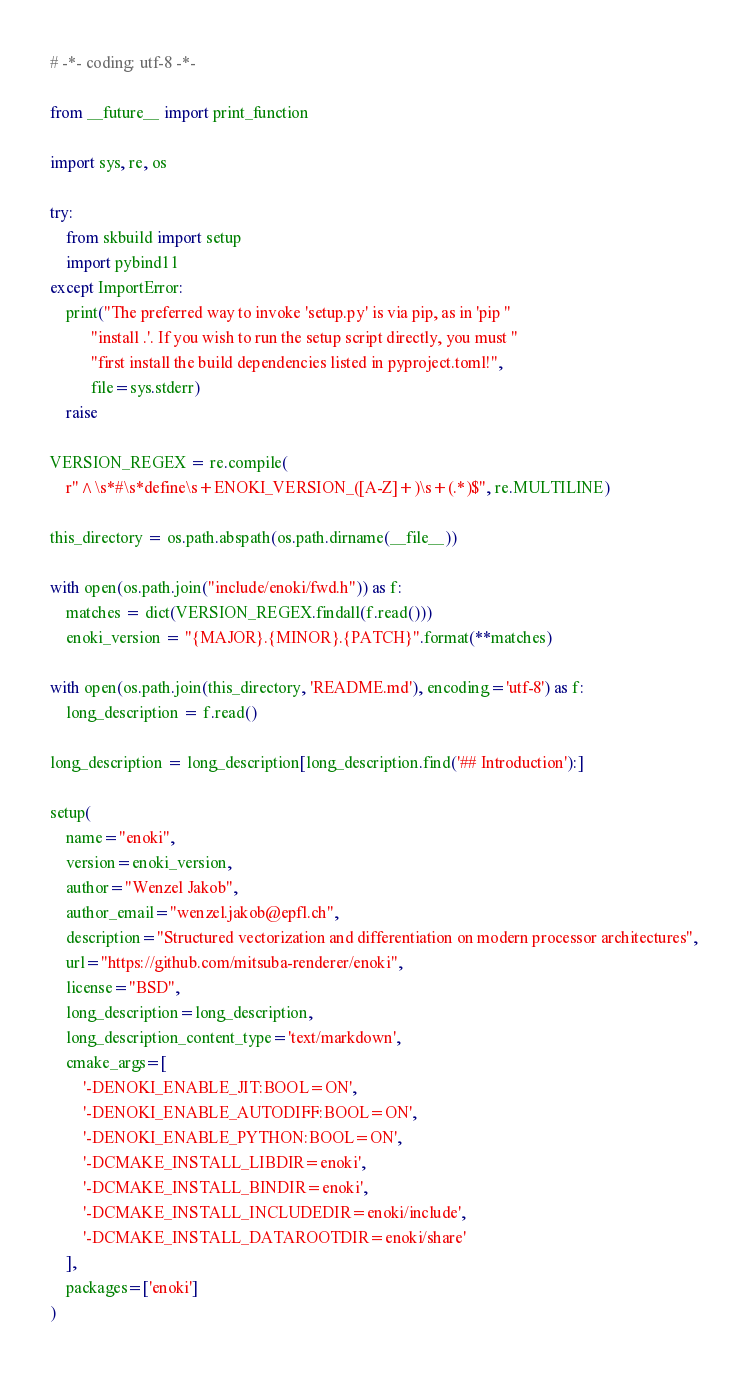<code> <loc_0><loc_0><loc_500><loc_500><_Python_># -*- coding: utf-8 -*-

from __future__ import print_function

import sys, re, os

try:
    from skbuild import setup
    import pybind11
except ImportError:
    print("The preferred way to invoke 'setup.py' is via pip, as in 'pip "
          "install .'. If you wish to run the setup script directly, you must "
          "first install the build dependencies listed in pyproject.toml!",
          file=sys.stderr)
    raise

VERSION_REGEX = re.compile(
    r"^\s*#\s*define\s+ENOKI_VERSION_([A-Z]+)\s+(.*)$", re.MULTILINE)

this_directory = os.path.abspath(os.path.dirname(__file__))

with open(os.path.join("include/enoki/fwd.h")) as f:
    matches = dict(VERSION_REGEX.findall(f.read()))
    enoki_version = "{MAJOR}.{MINOR}.{PATCH}".format(**matches)

with open(os.path.join(this_directory, 'README.md'), encoding='utf-8') as f:
    long_description = f.read()

long_description = long_description[long_description.find('## Introduction'):]

setup(
    name="enoki",
    version=enoki_version,
    author="Wenzel Jakob",
    author_email="wenzel.jakob@epfl.ch",
    description="Structured vectorization and differentiation on modern processor architectures",
    url="https://github.com/mitsuba-renderer/enoki",
    license="BSD",
    long_description=long_description,
    long_description_content_type='text/markdown',
    cmake_args=[
        '-DENOKI_ENABLE_JIT:BOOL=ON',
        '-DENOKI_ENABLE_AUTODIFF:BOOL=ON',
        '-DENOKI_ENABLE_PYTHON:BOOL=ON',
        '-DCMAKE_INSTALL_LIBDIR=enoki',
        '-DCMAKE_INSTALL_BINDIR=enoki',
        '-DCMAKE_INSTALL_INCLUDEDIR=enoki/include',
        '-DCMAKE_INSTALL_DATAROOTDIR=enoki/share'
    ],
    packages=['enoki']
)
</code> 